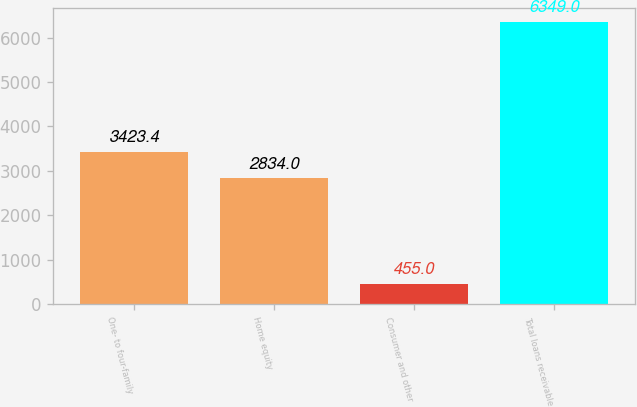<chart> <loc_0><loc_0><loc_500><loc_500><bar_chart><fcel>One- to four-family<fcel>Home equity<fcel>Consumer and other<fcel>Total loans receivable<nl><fcel>3423.4<fcel>2834<fcel>455<fcel>6349<nl></chart> 